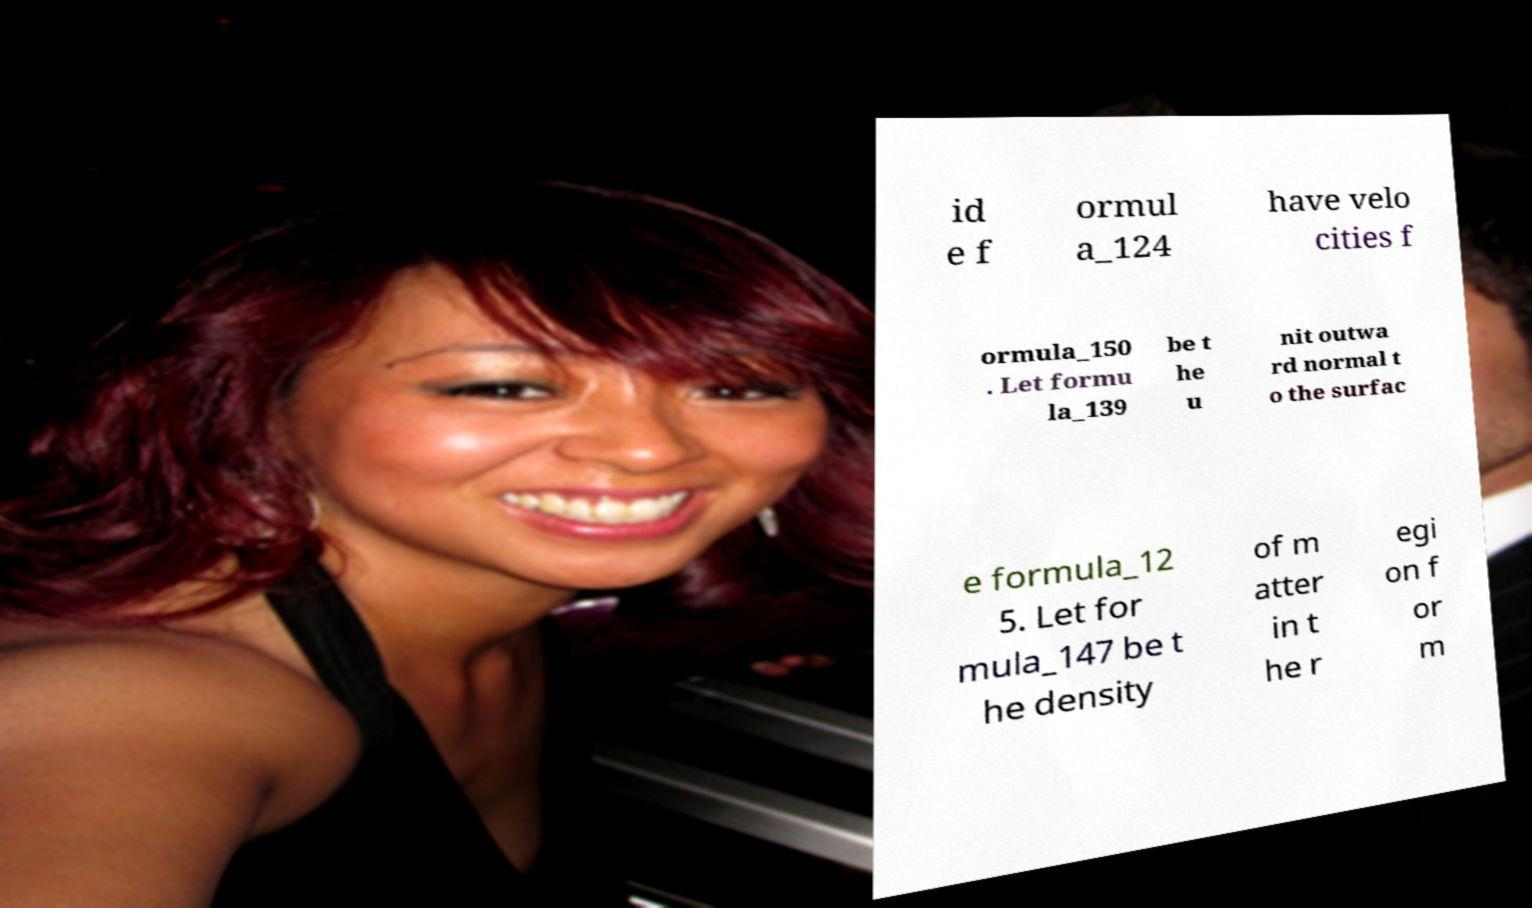Please read and relay the text visible in this image. What does it say? id e f ormul a_124 have velo cities f ormula_150 . Let formu la_139 be t he u nit outwa rd normal t o the surfac e formula_12 5. Let for mula_147 be t he density of m atter in t he r egi on f or m 